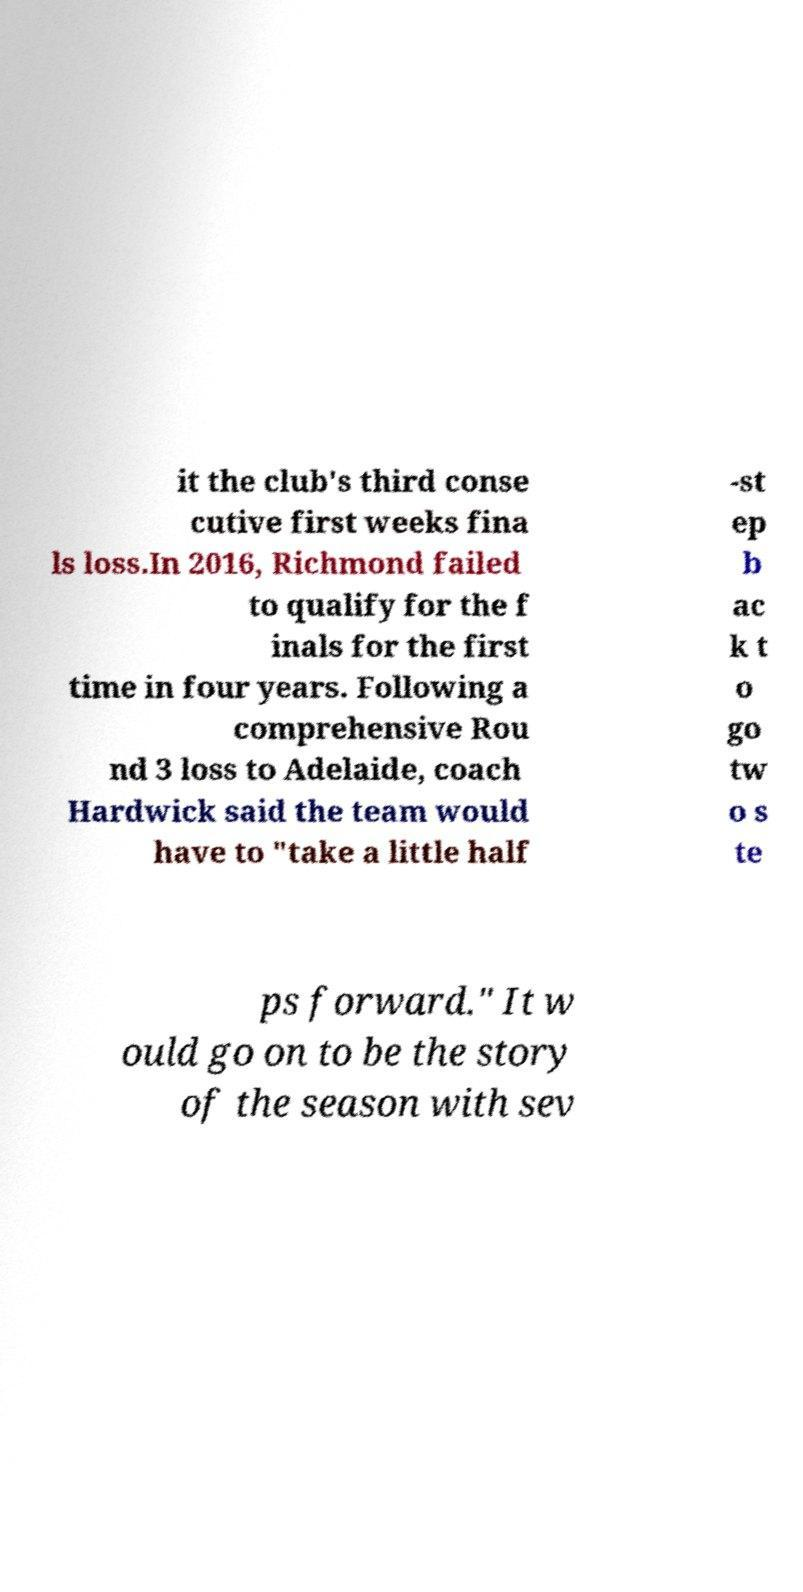Can you accurately transcribe the text from the provided image for me? it the club's third conse cutive first weeks fina ls loss.In 2016, Richmond failed to qualify for the f inals for the first time in four years. Following a comprehensive Rou nd 3 loss to Adelaide, coach Hardwick said the team would have to "take a little half -st ep b ac k t o go tw o s te ps forward." It w ould go on to be the story of the season with sev 